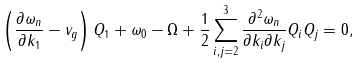Convert formula to latex. <formula><loc_0><loc_0><loc_500><loc_500>\left ( \frac { \partial \omega _ { n } } { \partial k _ { 1 } } - v _ { g } \right ) Q _ { 1 } + \omega _ { 0 } - \Omega + \frac { 1 } { 2 } \sum _ { i , j = 2 } ^ { 3 } \frac { \partial ^ { 2 } \omega _ { n } } { \partial k _ { i } \partial k _ { j } } Q _ { i } Q _ { j } = 0 ,</formula> 